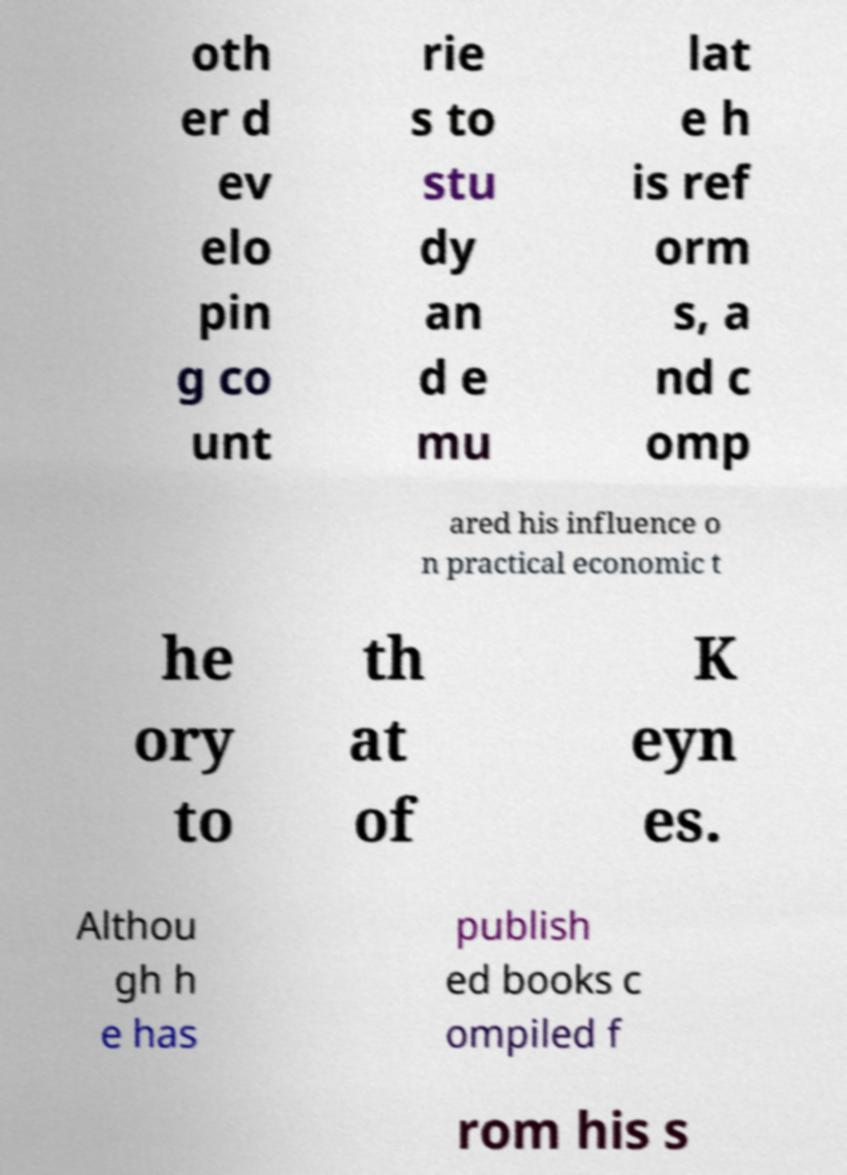Please read and relay the text visible in this image. What does it say? oth er d ev elo pin g co unt rie s to stu dy an d e mu lat e h is ref orm s, a nd c omp ared his influence o n practical economic t he ory to th at of K eyn es. Althou gh h e has publish ed books c ompiled f rom his s 